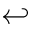Convert formula to latex. <formula><loc_0><loc_0><loc_500><loc_500>\hookleftarrow</formula> 